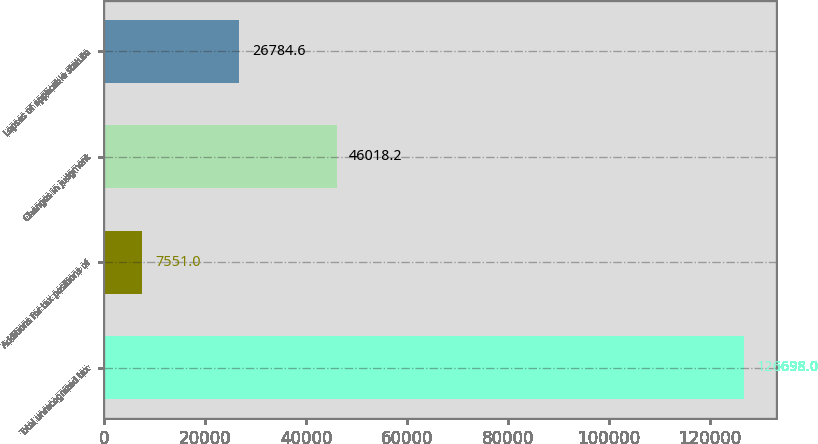Convert chart to OTSL. <chart><loc_0><loc_0><loc_500><loc_500><bar_chart><fcel>Total unrecognized tax<fcel>Additions for tax positions of<fcel>Changes in judgment<fcel>Lapses of applicable statute<nl><fcel>126698<fcel>7551<fcel>46018.2<fcel>26784.6<nl></chart> 